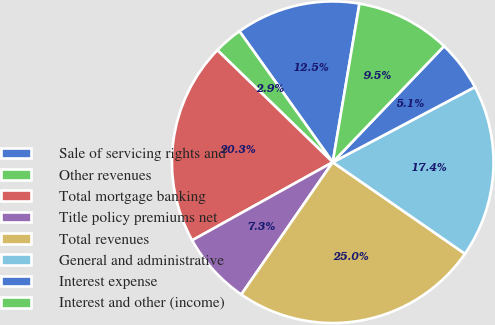Convert chart. <chart><loc_0><loc_0><loc_500><loc_500><pie_chart><fcel>Sale of servicing rights and<fcel>Other revenues<fcel>Total mortgage banking<fcel>Title policy premiums net<fcel>Total revenues<fcel>General and administrative<fcel>Interest expense<fcel>Interest and other (income)<nl><fcel>12.51%<fcel>2.88%<fcel>20.34%<fcel>7.3%<fcel>24.99%<fcel>17.38%<fcel>5.09%<fcel>9.51%<nl></chart> 